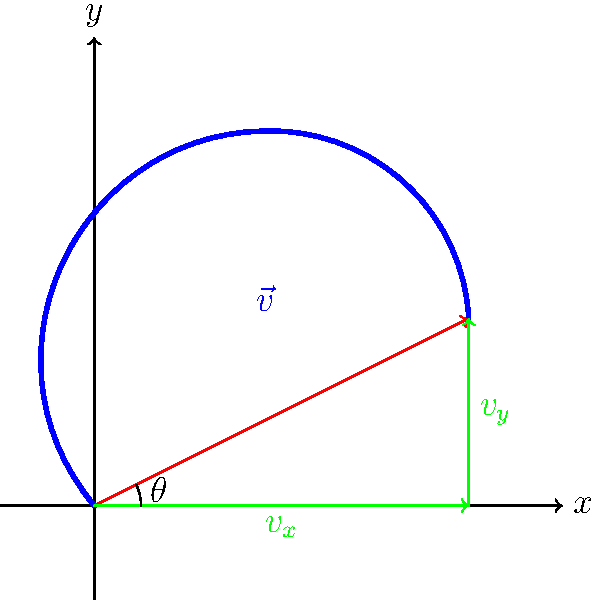A golfer's swing path is represented by the blue curve in the diagram. The final velocity vector $\vec{v}$ of the golf club head is shown in red. If the magnitude of the velocity vector is 50 m/s and the angle $\theta$ is 26.57°, calculate the x and y components of the velocity vector. To solve this problem, we'll use vector decomposition and trigonometric functions. Let's break it down step-by-step:

1. Given information:
   - Magnitude of velocity vector: $|\vec{v}| = 50$ m/s
   - Angle $\theta = 26.57°$

2. The x-component of the velocity vector is given by:
   $v_x = |\vec{v}| \cos(\theta)$

3. The y-component of the velocity vector is given by:
   $v_y = |\vec{v}| \sin(\theta)$

4. Calculate $v_x$:
   $v_x = 50 \cos(26.57°) = 50 \times 0.8944 = 44.72$ m/s

5. Calculate $v_y$:
   $v_y = 50 \sin(26.57°) = 50 \times 0.4472 = 22.36$ m/s

Therefore, the x-component of the velocity vector is 44.72 m/s, and the y-component is 22.36 m/s.
Answer: $v_x = 44.72$ m/s, $v_y = 22.36$ m/s 